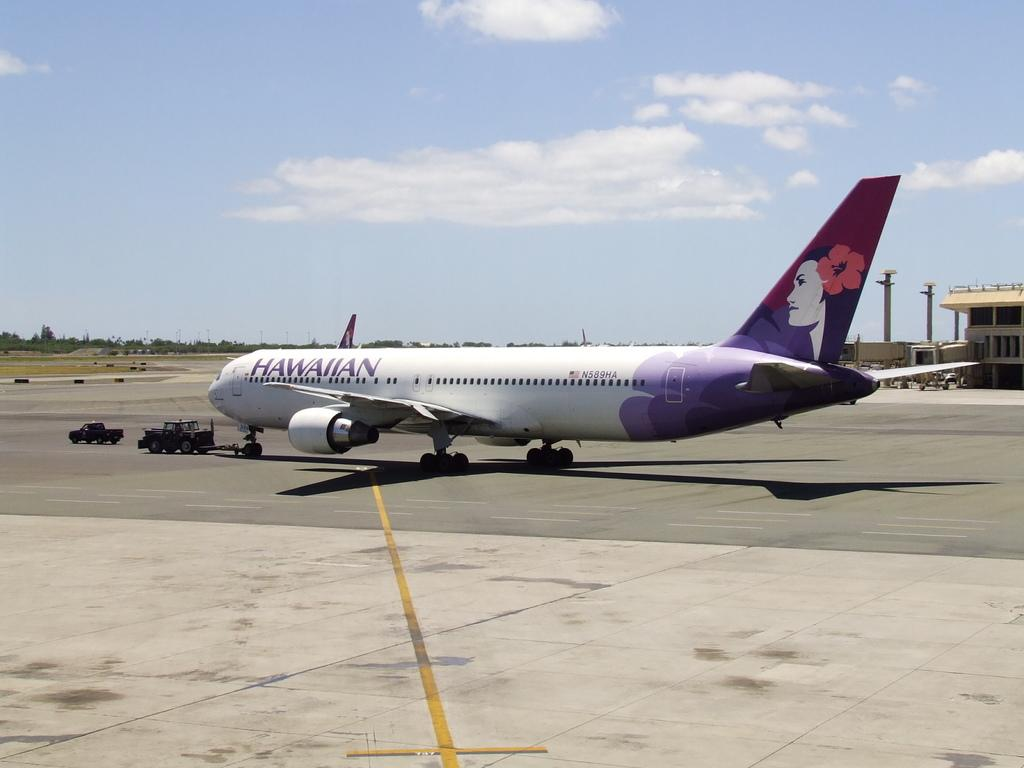<image>
Share a concise interpretation of the image provided. A plane with Hawaiian painted on its side. 